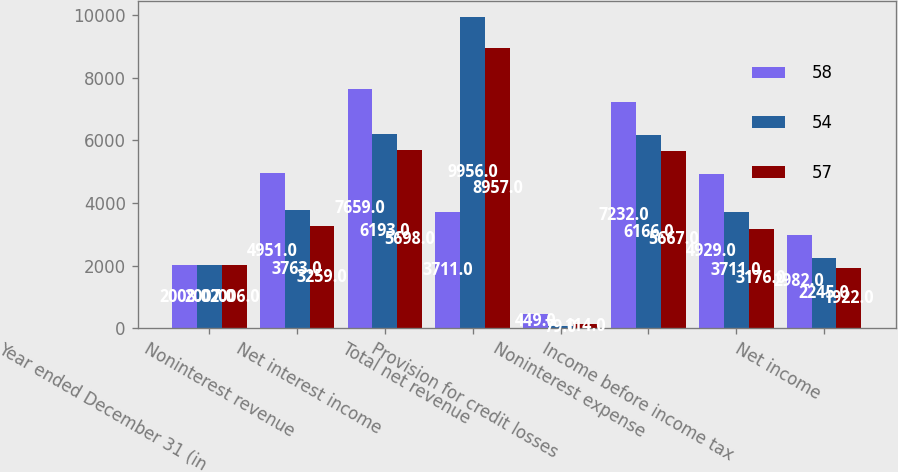<chart> <loc_0><loc_0><loc_500><loc_500><stacked_bar_chart><ecel><fcel>Year ended December 31 (in<fcel>Noninterest revenue<fcel>Net interest income<fcel>Total net revenue<fcel>Provision for credit losses<fcel>Noninterest expense<fcel>Income before income tax<fcel>Net income<nl><fcel>58<fcel>2008<fcel>4951<fcel>7659<fcel>3711<fcel>449<fcel>7232<fcel>4929<fcel>2982<nl><fcel>54<fcel>2007<fcel>3763<fcel>6193<fcel>9956<fcel>79<fcel>6166<fcel>3711<fcel>2245<nl><fcel>57<fcel>2006<fcel>3259<fcel>5698<fcel>8957<fcel>114<fcel>5667<fcel>3176<fcel>1922<nl></chart> 